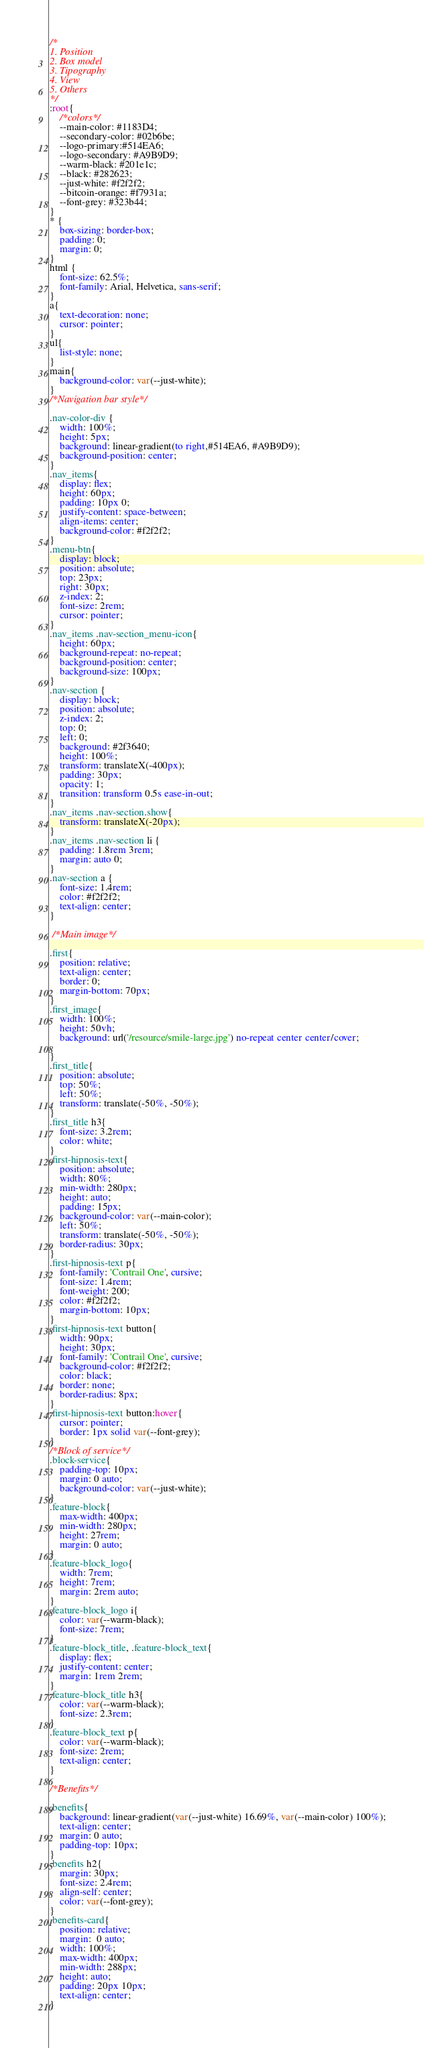Convert code to text. <code><loc_0><loc_0><loc_500><loc_500><_CSS_>/*
1. Position
2. Box model
3. Tipography
4. View
5. Others
*/
:root{
    /*colors*/
    --main-color: #1183D4;
    --secondary-color: #02b6be;
    --logo-primary:#514EA6;
    --logo-secondary: #A9B9D9;
    --warm-black: #201e1c;
    --black: #282623;
    --just-white: #f2f2f2;
    --bitcoin-orange: #f7931a;
    --font-grey: #323b44;
}
* {
    box-sizing: border-box;
    padding: 0;
    margin: 0;
}
html {
    font-size: 62.5%;
    font-family: Arial, Helvetica, sans-serif;
}
a{
    text-decoration: none;
    cursor: pointer;
}
ul{
    list-style: none;
}
main{
    background-color: var(--just-white);
} 
/*Navigation bar style*/

.nav-color-div {
    width: 100%;
    height: 5px;
    background: linear-gradient(to right,#514EA6, #A9B9D9); 
    background-position: center;
}
.nav_items{
    display: flex;
    height: 60px;
    padding: 10px 0;
    justify-content: space-between;
    align-items: center;
    background-color: #f2f2f2;
}
.menu-btn{
    display: block;
    position: absolute;
    top: 23px;
    right: 30px;
    z-index: 2;
    font-size: 2rem;
    cursor: pointer;
}
.nav_items .nav-section_menu-icon{
    height: 60px;
    background-repeat: no-repeat;
    background-position: center;
    background-size: 100px;
}
.nav-section {
    display: block;
    position: absolute;
    z-index: 2;
    top: 0;
    left: 0;
    background: #2f3640;
    height: 100%;
    transform: translateX(-400px);
    padding: 30px;
    opacity: 1;
    transition: transform 0.5s ease-in-out;
}
.nav_items .nav-section.show{
    transform: translateX(-20px);
}
.nav_items .nav-section li {
    padding: 1.8rem 3rem;
    margin: auto 0;
}
.nav-section a {
    font-size: 1.4rem;
    color: #f2f2f2;
    text-align: center;
}

 /*Main image*/

.first{
    position: relative;
    text-align: center;
    border: 0;
    margin-bottom: 70px;
}
.first_image{
    width: 100%;
    height: 50vh;
    background: url('/resource/smile-large.jpg') no-repeat center center/cover;

}
.first_title{
    position: absolute;
    top: 50%;
    left: 50%;
    transform: translate(-50%, -50%);
}
.first_title h3{
    font-size: 3.2rem;
    color: white;
}
.first-hipnosis-text{
    position: absolute;
    width: 80%;
    min-width: 280px;
    height: auto;
    padding: 15px;
    background-color: var(--main-color);
    left: 50%;
    transform: translate(-50%, -50%);
    border-radius: 30px;
}
.first-hipnosis-text p{
    font-family: 'Contrail One', cursive;
    font-size: 1.4rem;
    font-weight: 200;
    color: #f2f2f2;
    margin-bottom: 10px;
}
.first-hipnosis-text button{
    width: 90px;
    height: 30px;
    font-family: 'Contrail One', cursive;
    background-color: #f2f2f2;
    color: black;
    border: none;
    border-radius: 8px;
}
.first-hipnosis-text button:hover{
    cursor: pointer;
    border: 1px solid var(--font-grey);
}
/*Block of service*/
.block-service{
    padding-top: 10px;
    margin: 0 auto;
    background-color: var(--just-white);
}
.feature-block{
    max-width: 400px;
    min-width: 280px;
    height: 27rem;
    margin: 0 auto;
}
.feature-block_logo{
    width: 7rem;
    height: 7rem;
    margin: 2rem auto;
}
.feature-block_logo i{
    color: var(--warm-black);
    font-size: 7rem;
}
.feature-block_title, .feature-block_text{
    display: flex;
    justify-content: center;
    margin: 1rem 2rem;
}
.feature-block_title h3{
    color: var(--warm-black);
    font-size: 2.3rem;
}
.feature-block_text p{
    color: var(--warm-black);
    font-size: 2rem;
    text-align: center;
}

/*Benefits*/

.benefits{
    background: linear-gradient(var(--just-white) 16.69%, var(--main-color) 100%);
    text-align: center;
    margin: 0 auto;
    padding-top: 10px;
}
.benefits h2{
    margin: 30px;
    font-size: 2.4rem;
    align-self: center;
    color: var(--font-grey);
}
.benefits-card{
    position: relative;
    margin:  0 auto;
    width: 100%;
    max-width: 400px;
    min-width: 288px;
    height: auto;
    padding: 20px 10px;
    text-align: center;
}</code> 